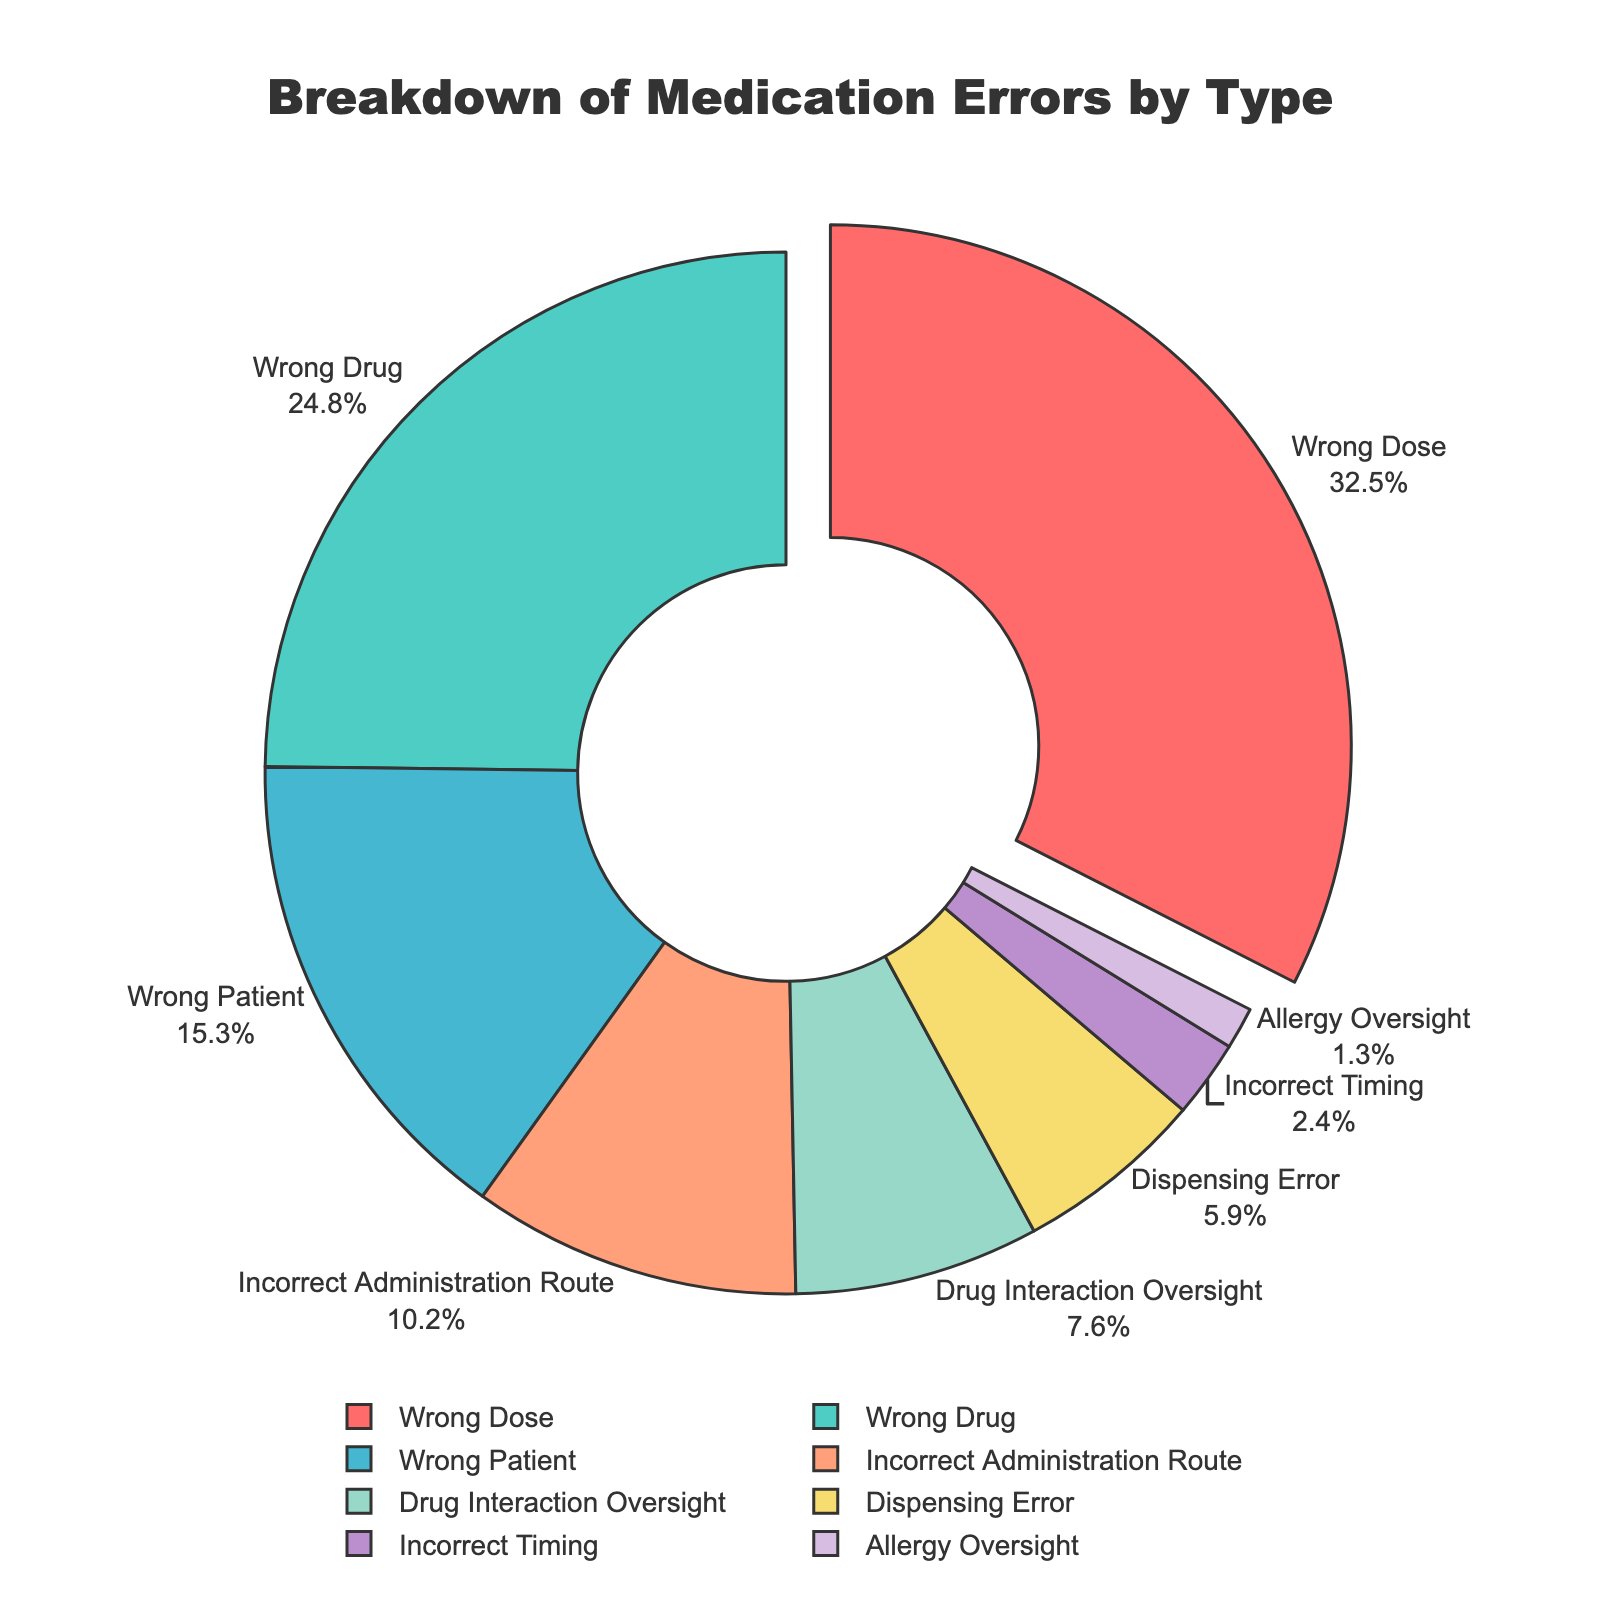What type of medication error is the most common? The figure shows that the largest portion of the pie is labeled "Wrong Dose" which has the highest percentage.
Answer: Wrong Dose Which type of medication error occurs more frequently: dispensing error or incorrect administration route? By comparing the size of the pie segments and their corresponding percentages, 10.2% belong to "Incorrect Administration Route" and 5.9% to "Dispensing Error." Therefore, Incorrect Administration Route occurs more frequently.
Answer: Incorrect Administration Route What percentage of medication errors are due to wrong dose and wrong drug combined? The percentage for wrong dose is 32.5% and for wrong drug is 24.8%. Adding these together: 32.5 + 24.8 = 57.3%.
Answer: 57.3% Which medication error type contributes the least to the total errors? By identifying the smallest segment in the pie chart, the "Allergy Oversight" segment is the smallest with a percentage of 1.3%.
Answer: Allergy Oversight Are medication errors involving the wrong patient more or less frequent than those involving drug interaction oversight? Comparing the sizes of the pie segments, "Wrong Patient" has a percentage of 15.3%, which is greater than "Drug Interaction Oversight" at 7.6%. Thus, wrong patient errors are more frequent.
Answer: More frequent What is the total percentage of errors caused by drug interaction oversight, incorrect timing, and allergy oversight? We sum up the percentages for drug interaction oversight (7.6%), incorrect timing (2.4%), and allergy oversight (1.3%): 7.6 + 2.4 + 1.3 = 11.3%.
Answer: 11.3% By how much does the percentage of wrong drug errors exceed the percentage of incorrect administration route errors? The percentage for wrong drug errors is 24.8%, and for incorrect administration route errors, it is 10.2%. Subtracting these gives: 24.8 - 10.2 = 14.6%.
Answer: 14.6% Which type of error is highlighted (pulled out) in the pie chart? Observing the visual cues in the pie chart, the segment that is pulled out or highlighted is "Wrong Dose."
Answer: Wrong Dose What is the average percentage of errors not associated with wrong dose, wrong drug, and wrong patient? The percentages not associated with wrong dose (32.5%), wrong drug (24.8%), and wrong patient (15.3%) include: incorrect administration route (10.2%), drug interaction oversight (7.6%), dispensing error (5.9%), incorrect timing (2.4%), and allergy oversight (1.3%). Their total is: 10.2 + 7.6 + 5.9 + 2.4 + 1.3 = 27.4%. We then divide by 5 (the number of remaining categories): 27.4 / 5 = 5.48%.
Answer: 5.48% What is the difference between the highest and lowest percentages of medication error types? The highest percentage is for wrong dose (32.5%) and the lowest is for allergy oversight (1.3%). Subtracting these gives: 32.5 - 1.3 = 31.2%.
Answer: 31.2% 